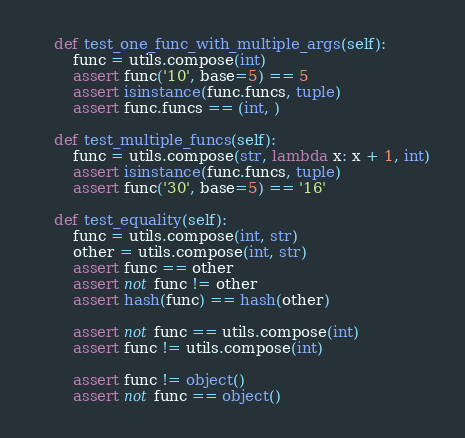<code> <loc_0><loc_0><loc_500><loc_500><_Python_>
    def test_one_func_with_multiple_args(self):
        func = utils.compose(int)
        assert func('10', base=5) == 5
        assert isinstance(func.funcs, tuple)
        assert func.funcs == (int, )

    def test_multiple_funcs(self):
        func = utils.compose(str, lambda x: x + 1, int)
        assert isinstance(func.funcs, tuple)
        assert func('30', base=5) == '16'

    def test_equality(self):
        func = utils.compose(int, str)
        other = utils.compose(int, str)
        assert func == other
        assert not func != other
        assert hash(func) == hash(other)

        assert not func == utils.compose(int)
        assert func != utils.compose(int)

        assert func != object()
        assert not func == object()
</code> 